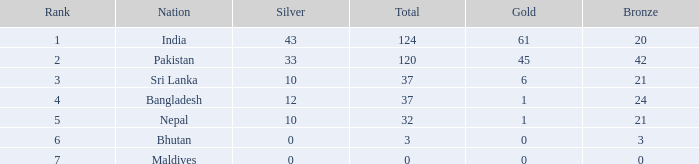Which gold has a rank less than 5, and a bronze of 20? 61.0. 